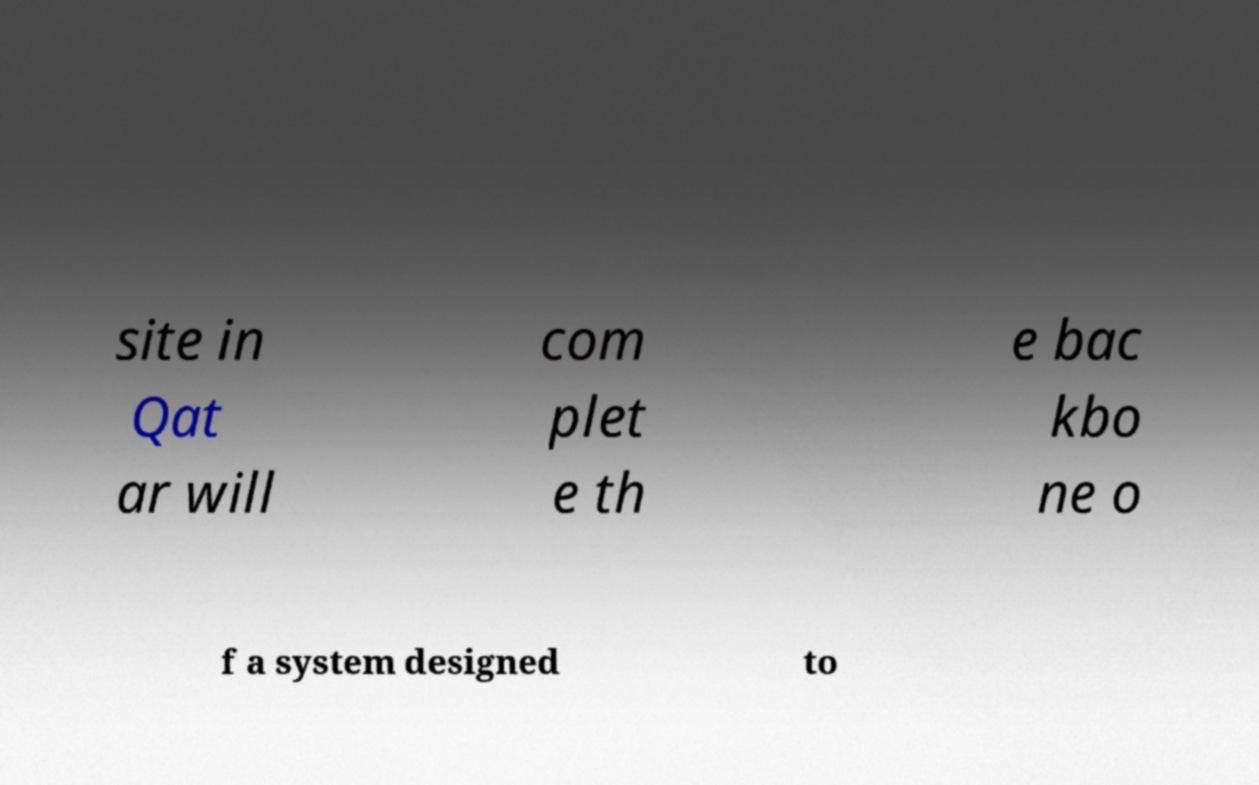I need the written content from this picture converted into text. Can you do that? site in Qat ar will com plet e th e bac kbo ne o f a system designed to 